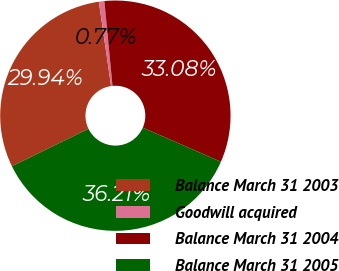Convert chart. <chart><loc_0><loc_0><loc_500><loc_500><pie_chart><fcel>Balance March 31 2003<fcel>Goodwill acquired<fcel>Balance March 31 2004<fcel>Balance March 31 2005<nl><fcel>29.94%<fcel>0.77%<fcel>33.08%<fcel>36.21%<nl></chart> 